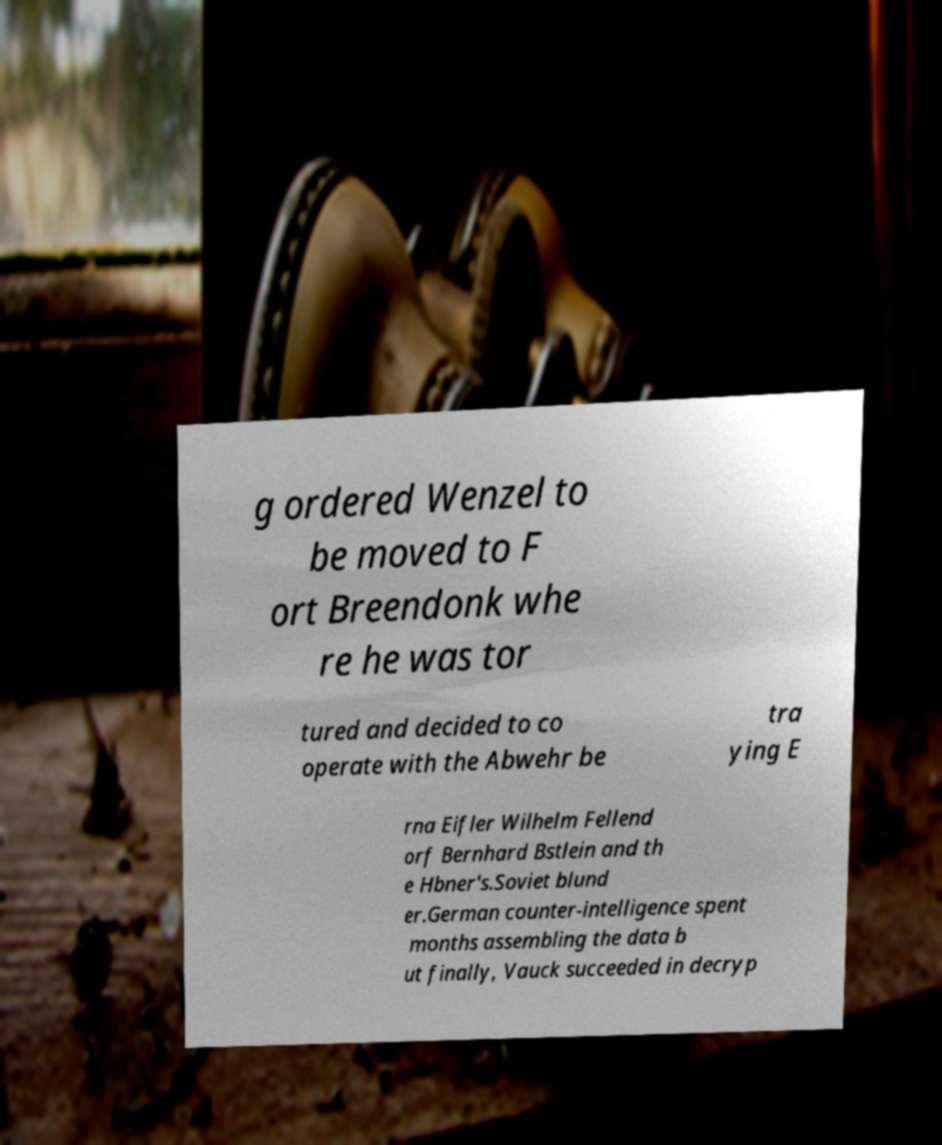Could you assist in decoding the text presented in this image and type it out clearly? g ordered Wenzel to be moved to F ort Breendonk whe re he was tor tured and decided to co operate with the Abwehr be tra ying E rna Eifler Wilhelm Fellend orf Bernhard Bstlein and th e Hbner's.Soviet blund er.German counter-intelligence spent months assembling the data b ut finally, Vauck succeeded in decryp 